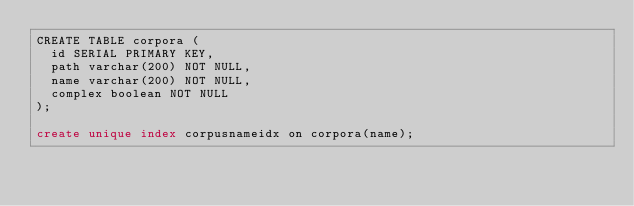<code> <loc_0><loc_0><loc_500><loc_500><_SQL_>CREATE TABLE corpora (
  id SERIAL PRIMARY KEY,
  path varchar(200) NOT NULL,
  name varchar(200) NOT NULL,
  complex boolean NOT NULL
);

create unique index corpusnameidx on corpora(name);
</code> 